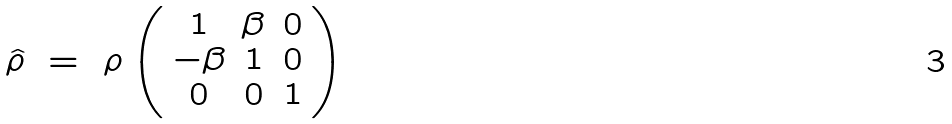Convert formula to latex. <formula><loc_0><loc_0><loc_500><loc_500>\hat { \rho } \ = \ \rho \left ( \begin{array} { c c c } 1 & \beta & 0 \\ - \beta & 1 & 0 \\ 0 & 0 & 1 \end{array} \right )</formula> 